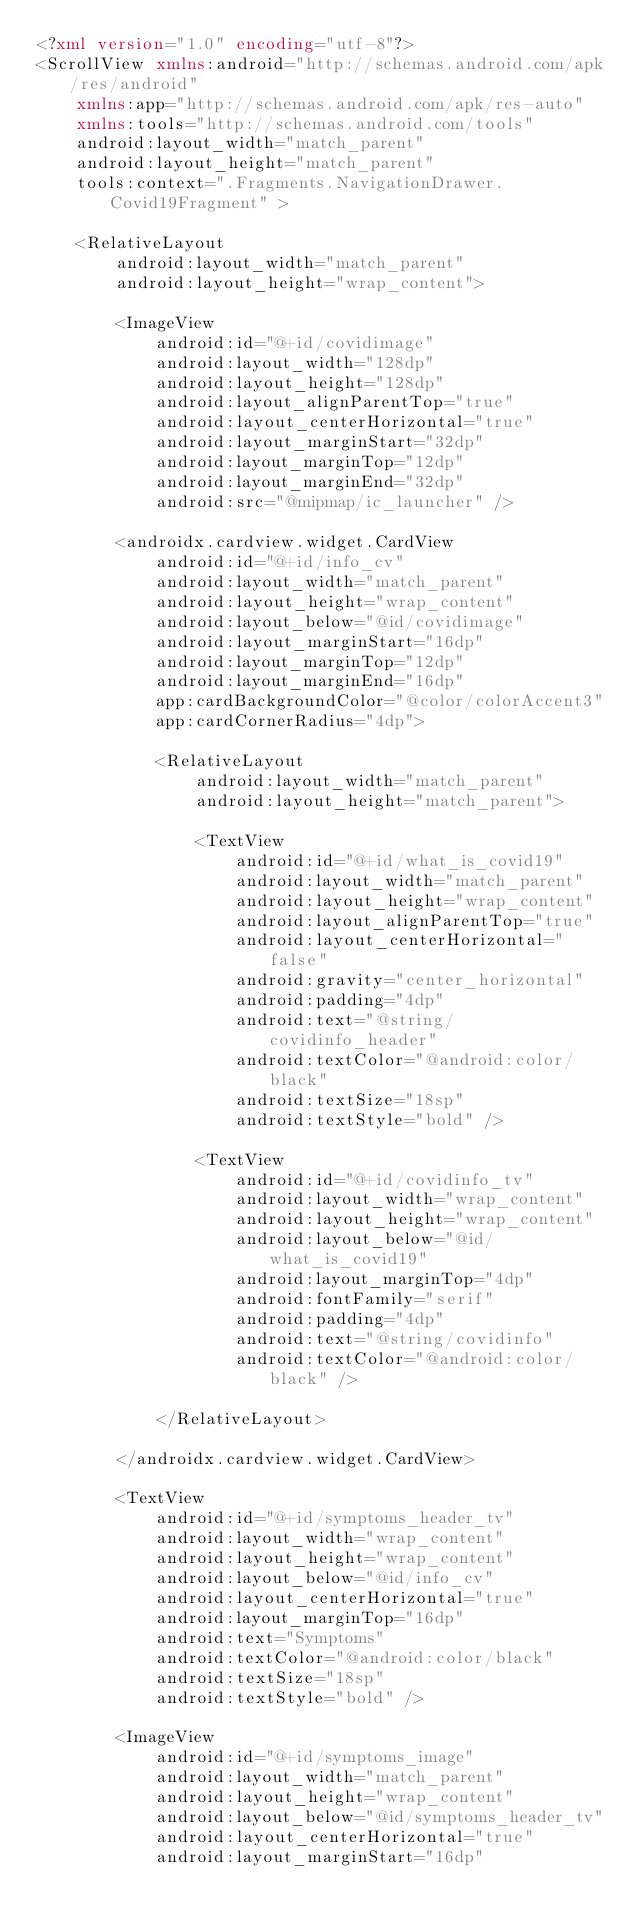<code> <loc_0><loc_0><loc_500><loc_500><_XML_><?xml version="1.0" encoding="utf-8"?>
<ScrollView xmlns:android="http://schemas.android.com/apk/res/android"
    xmlns:app="http://schemas.android.com/apk/res-auto"
    xmlns:tools="http://schemas.android.com/tools"
    android:layout_width="match_parent"
    android:layout_height="match_parent"
    tools:context=".Fragments.NavigationDrawer.Covid19Fragment" >

    <RelativeLayout
        android:layout_width="match_parent"
        android:layout_height="wrap_content">

        <ImageView
            android:id="@+id/covidimage"
            android:layout_width="128dp"
            android:layout_height="128dp"
            android:layout_alignParentTop="true"
            android:layout_centerHorizontal="true"
            android:layout_marginStart="32dp"
            android:layout_marginTop="12dp"
            android:layout_marginEnd="32dp"
            android:src="@mipmap/ic_launcher" />

        <androidx.cardview.widget.CardView
            android:id="@+id/info_cv"
            android:layout_width="match_parent"
            android:layout_height="wrap_content"
            android:layout_below="@id/covidimage"
            android:layout_marginStart="16dp"
            android:layout_marginTop="12dp"
            android:layout_marginEnd="16dp"
            app:cardBackgroundColor="@color/colorAccent3"
            app:cardCornerRadius="4dp">

            <RelativeLayout
                android:layout_width="match_parent"
                android:layout_height="match_parent">

                <TextView
                    android:id="@+id/what_is_covid19"
                    android:layout_width="match_parent"
                    android:layout_height="wrap_content"
                    android:layout_alignParentTop="true"
                    android:layout_centerHorizontal="false"
                    android:gravity="center_horizontal"
                    android:padding="4dp"
                    android:text="@string/covidinfo_header"
                    android:textColor="@android:color/black"
                    android:textSize="18sp"
                    android:textStyle="bold" />

                <TextView
                    android:id="@+id/covidinfo_tv"
                    android:layout_width="wrap_content"
                    android:layout_height="wrap_content"
                    android:layout_below="@id/what_is_covid19"
                    android:layout_marginTop="4dp"
                    android:fontFamily="serif"
                    android:padding="4dp"
                    android:text="@string/covidinfo"
                    android:textColor="@android:color/black" />

            </RelativeLayout>

        </androidx.cardview.widget.CardView>

        <TextView
            android:id="@+id/symptoms_header_tv"
            android:layout_width="wrap_content"
            android:layout_height="wrap_content"
            android:layout_below="@id/info_cv"
            android:layout_centerHorizontal="true"
            android:layout_marginTop="16dp"
            android:text="Symptoms"
            android:textColor="@android:color/black"
            android:textSize="18sp"
            android:textStyle="bold" />

        <ImageView
            android:id="@+id/symptoms_image"
            android:layout_width="match_parent"
            android:layout_height="wrap_content"
            android:layout_below="@id/symptoms_header_tv"
            android:layout_centerHorizontal="true"
            android:layout_marginStart="16dp"</code> 